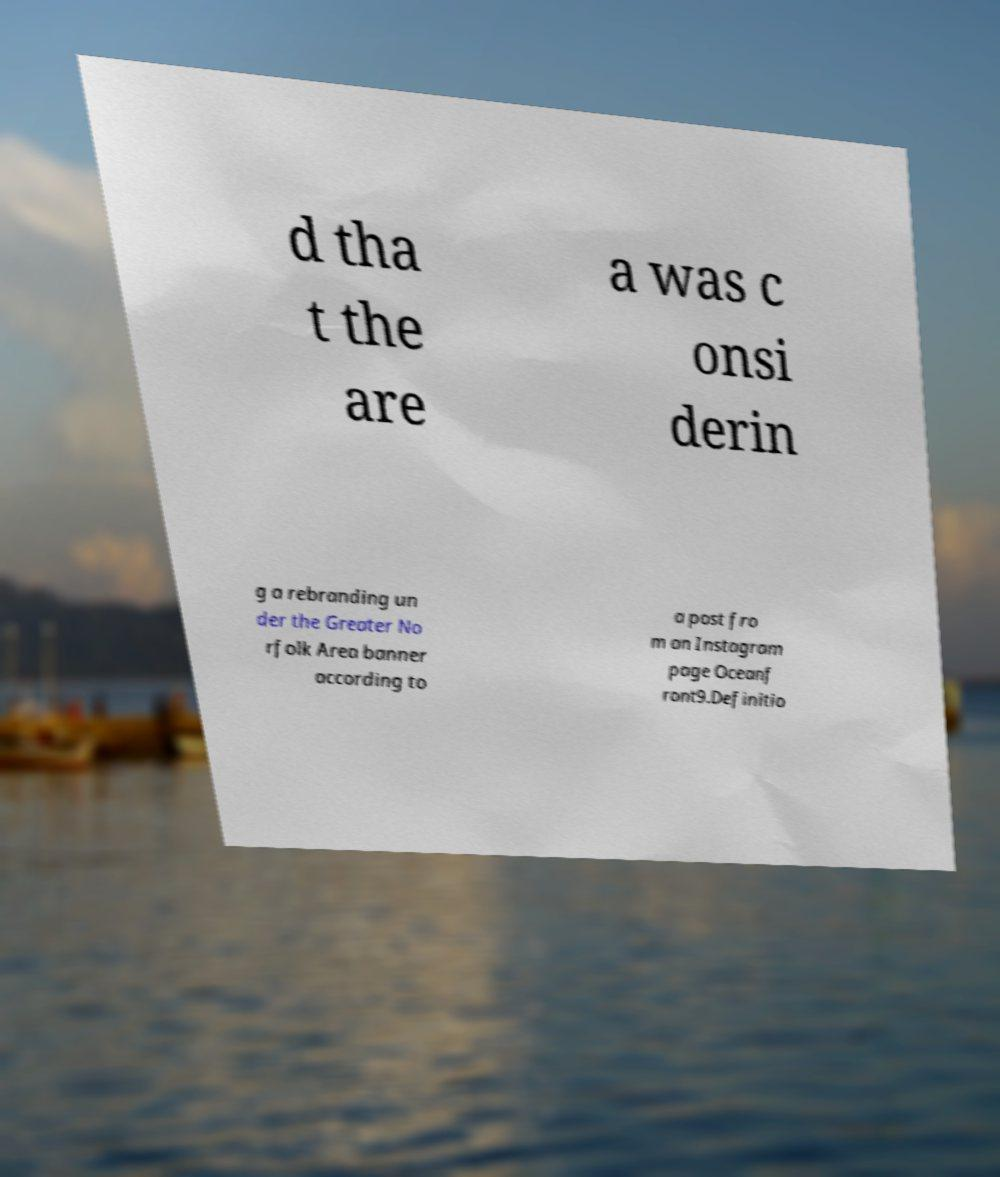Please read and relay the text visible in this image. What does it say? d tha t the are a was c onsi derin g a rebranding un der the Greater No rfolk Area banner according to a post fro m an Instagram page Oceanf ront9.Definitio 